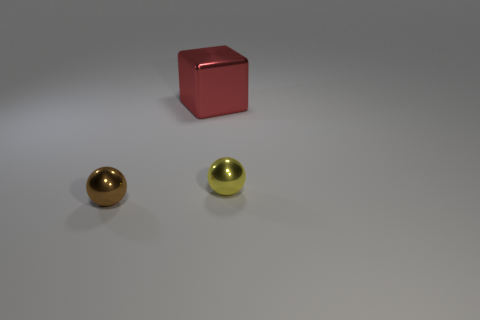If I were creating a physics experiment, what characteristics of these objects might be valuable to me? In a physics context, these objects offer several valuable characteristics for study. The cube, with its regular and symmetrical dimensions, would be excellent for exploring principles related to reflection and absorption with its uniform surfaces. The spheres might be used to demonstrate rolling motion, momentum, and kinetic energy, with their polished surfaces aiding in reducing friction. The differing materials and color properties of the objects could also be great for experiments related to thermal dynamics, as different colors and materials can absorb and emit heat differently. 